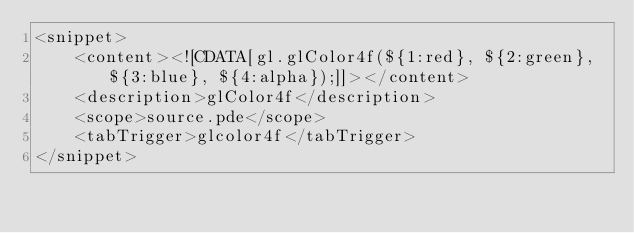Convert code to text. <code><loc_0><loc_0><loc_500><loc_500><_XML_><snippet>
    <content><![CDATA[gl.glColor4f(${1:red}, ${2:green}, ${3:blue}, ${4:alpha});]]></content>
    <description>glColor4f</description>
    <scope>source.pde</scope>
    <tabTrigger>glcolor4f</tabTrigger>
</snippet>
</code> 